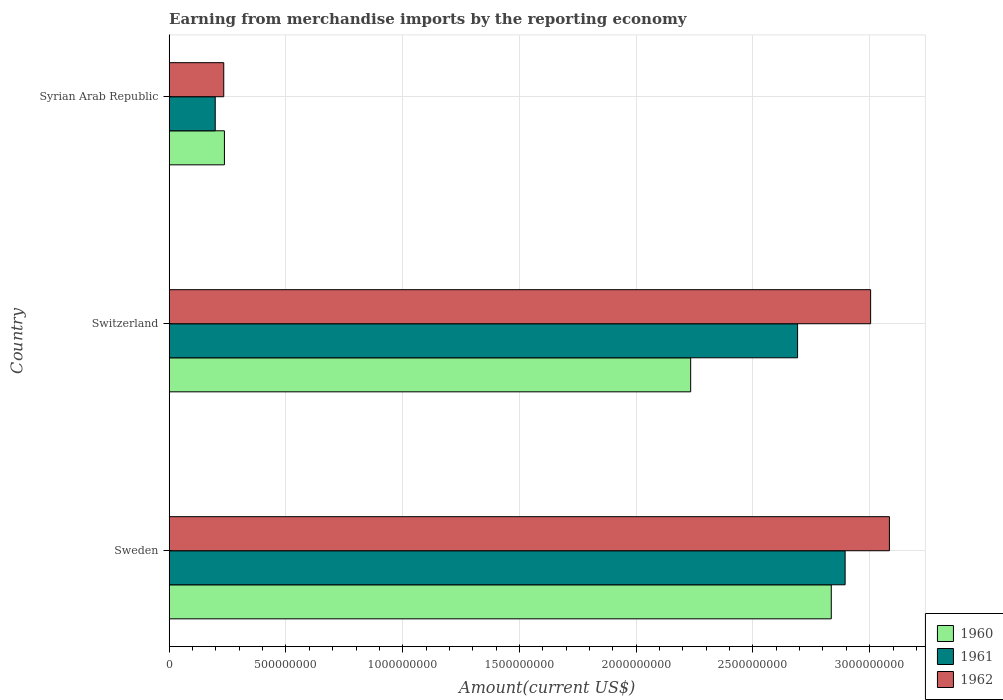How many groups of bars are there?
Keep it short and to the point. 3. Are the number of bars on each tick of the Y-axis equal?
Your response must be concise. Yes. How many bars are there on the 3rd tick from the bottom?
Offer a terse response. 3. What is the label of the 2nd group of bars from the top?
Make the answer very short. Switzerland. What is the amount earned from merchandise imports in 1960 in Switzerland?
Offer a terse response. 2.23e+09. Across all countries, what is the maximum amount earned from merchandise imports in 1960?
Your response must be concise. 2.84e+09. Across all countries, what is the minimum amount earned from merchandise imports in 1962?
Keep it short and to the point. 2.34e+08. In which country was the amount earned from merchandise imports in 1960 maximum?
Provide a succinct answer. Sweden. In which country was the amount earned from merchandise imports in 1962 minimum?
Offer a terse response. Syrian Arab Republic. What is the total amount earned from merchandise imports in 1962 in the graph?
Ensure brevity in your answer.  6.32e+09. What is the difference between the amount earned from merchandise imports in 1962 in Sweden and that in Syrian Arab Republic?
Your answer should be very brief. 2.85e+09. What is the difference between the amount earned from merchandise imports in 1960 in Syrian Arab Republic and the amount earned from merchandise imports in 1962 in Switzerland?
Your answer should be compact. -2.77e+09. What is the average amount earned from merchandise imports in 1962 per country?
Give a very brief answer. 2.11e+09. What is the difference between the amount earned from merchandise imports in 1961 and amount earned from merchandise imports in 1962 in Switzerland?
Give a very brief answer. -3.13e+08. In how many countries, is the amount earned from merchandise imports in 1960 greater than 1400000000 US$?
Your answer should be compact. 2. What is the ratio of the amount earned from merchandise imports in 1960 in Sweden to that in Syrian Arab Republic?
Provide a short and direct response. 11.99. Is the difference between the amount earned from merchandise imports in 1961 in Sweden and Switzerland greater than the difference between the amount earned from merchandise imports in 1962 in Sweden and Switzerland?
Offer a terse response. Yes. What is the difference between the highest and the second highest amount earned from merchandise imports in 1962?
Keep it short and to the point. 8.05e+07. What is the difference between the highest and the lowest amount earned from merchandise imports in 1960?
Ensure brevity in your answer.  2.60e+09. Is the sum of the amount earned from merchandise imports in 1961 in Switzerland and Syrian Arab Republic greater than the maximum amount earned from merchandise imports in 1960 across all countries?
Your response must be concise. Yes. What does the 3rd bar from the bottom in Sweden represents?
Provide a succinct answer. 1962. Is it the case that in every country, the sum of the amount earned from merchandise imports in 1961 and amount earned from merchandise imports in 1962 is greater than the amount earned from merchandise imports in 1960?
Keep it short and to the point. Yes. How many bars are there?
Your answer should be very brief. 9. Are all the bars in the graph horizontal?
Your answer should be compact. Yes. What is the difference between two consecutive major ticks on the X-axis?
Provide a short and direct response. 5.00e+08. Are the values on the major ticks of X-axis written in scientific E-notation?
Provide a succinct answer. No. How many legend labels are there?
Offer a terse response. 3. How are the legend labels stacked?
Ensure brevity in your answer.  Vertical. What is the title of the graph?
Keep it short and to the point. Earning from merchandise imports by the reporting economy. What is the label or title of the X-axis?
Offer a very short reply. Amount(current US$). What is the label or title of the Y-axis?
Provide a short and direct response. Country. What is the Amount(current US$) in 1960 in Sweden?
Your answer should be compact. 2.84e+09. What is the Amount(current US$) of 1961 in Sweden?
Ensure brevity in your answer.  2.89e+09. What is the Amount(current US$) in 1962 in Sweden?
Keep it short and to the point. 3.08e+09. What is the Amount(current US$) in 1960 in Switzerland?
Make the answer very short. 2.23e+09. What is the Amount(current US$) in 1961 in Switzerland?
Offer a very short reply. 2.69e+09. What is the Amount(current US$) in 1962 in Switzerland?
Offer a terse response. 3.00e+09. What is the Amount(current US$) in 1960 in Syrian Arab Republic?
Make the answer very short. 2.36e+08. What is the Amount(current US$) of 1961 in Syrian Arab Republic?
Offer a terse response. 1.97e+08. What is the Amount(current US$) in 1962 in Syrian Arab Republic?
Offer a very short reply. 2.34e+08. Across all countries, what is the maximum Amount(current US$) in 1960?
Offer a very short reply. 2.84e+09. Across all countries, what is the maximum Amount(current US$) of 1961?
Ensure brevity in your answer.  2.89e+09. Across all countries, what is the maximum Amount(current US$) of 1962?
Provide a short and direct response. 3.08e+09. Across all countries, what is the minimum Amount(current US$) in 1960?
Keep it short and to the point. 2.36e+08. Across all countries, what is the minimum Amount(current US$) in 1961?
Your response must be concise. 1.97e+08. Across all countries, what is the minimum Amount(current US$) of 1962?
Offer a terse response. 2.34e+08. What is the total Amount(current US$) in 1960 in the graph?
Provide a short and direct response. 5.31e+09. What is the total Amount(current US$) in 1961 in the graph?
Your response must be concise. 5.78e+09. What is the total Amount(current US$) of 1962 in the graph?
Make the answer very short. 6.32e+09. What is the difference between the Amount(current US$) of 1960 in Sweden and that in Switzerland?
Your answer should be very brief. 6.02e+08. What is the difference between the Amount(current US$) of 1961 in Sweden and that in Switzerland?
Offer a very short reply. 2.04e+08. What is the difference between the Amount(current US$) in 1962 in Sweden and that in Switzerland?
Offer a very short reply. 8.05e+07. What is the difference between the Amount(current US$) of 1960 in Sweden and that in Syrian Arab Republic?
Keep it short and to the point. 2.60e+09. What is the difference between the Amount(current US$) of 1961 in Sweden and that in Syrian Arab Republic?
Make the answer very short. 2.70e+09. What is the difference between the Amount(current US$) in 1962 in Sweden and that in Syrian Arab Republic?
Offer a terse response. 2.85e+09. What is the difference between the Amount(current US$) in 1960 in Switzerland and that in Syrian Arab Republic?
Your answer should be compact. 2.00e+09. What is the difference between the Amount(current US$) in 1961 in Switzerland and that in Syrian Arab Republic?
Offer a terse response. 2.49e+09. What is the difference between the Amount(current US$) in 1962 in Switzerland and that in Syrian Arab Republic?
Offer a terse response. 2.77e+09. What is the difference between the Amount(current US$) of 1960 in Sweden and the Amount(current US$) of 1961 in Switzerland?
Your answer should be compact. 1.44e+08. What is the difference between the Amount(current US$) in 1960 in Sweden and the Amount(current US$) in 1962 in Switzerland?
Your answer should be compact. -1.68e+08. What is the difference between the Amount(current US$) in 1961 in Sweden and the Amount(current US$) in 1962 in Switzerland?
Ensure brevity in your answer.  -1.09e+08. What is the difference between the Amount(current US$) in 1960 in Sweden and the Amount(current US$) in 1961 in Syrian Arab Republic?
Provide a succinct answer. 2.64e+09. What is the difference between the Amount(current US$) in 1960 in Sweden and the Amount(current US$) in 1962 in Syrian Arab Republic?
Keep it short and to the point. 2.60e+09. What is the difference between the Amount(current US$) of 1961 in Sweden and the Amount(current US$) of 1962 in Syrian Arab Republic?
Offer a very short reply. 2.66e+09. What is the difference between the Amount(current US$) in 1960 in Switzerland and the Amount(current US$) in 1961 in Syrian Arab Republic?
Your answer should be compact. 2.04e+09. What is the difference between the Amount(current US$) of 1960 in Switzerland and the Amount(current US$) of 1962 in Syrian Arab Republic?
Offer a very short reply. 2.00e+09. What is the difference between the Amount(current US$) in 1961 in Switzerland and the Amount(current US$) in 1962 in Syrian Arab Republic?
Your answer should be compact. 2.46e+09. What is the average Amount(current US$) in 1960 per country?
Your response must be concise. 1.77e+09. What is the average Amount(current US$) in 1961 per country?
Offer a very short reply. 1.93e+09. What is the average Amount(current US$) in 1962 per country?
Ensure brevity in your answer.  2.11e+09. What is the difference between the Amount(current US$) of 1960 and Amount(current US$) of 1961 in Sweden?
Give a very brief answer. -5.93e+07. What is the difference between the Amount(current US$) of 1960 and Amount(current US$) of 1962 in Sweden?
Your answer should be very brief. -2.49e+08. What is the difference between the Amount(current US$) of 1961 and Amount(current US$) of 1962 in Sweden?
Offer a terse response. -1.90e+08. What is the difference between the Amount(current US$) in 1960 and Amount(current US$) in 1961 in Switzerland?
Provide a succinct answer. -4.58e+08. What is the difference between the Amount(current US$) of 1960 and Amount(current US$) of 1962 in Switzerland?
Provide a succinct answer. -7.71e+08. What is the difference between the Amount(current US$) in 1961 and Amount(current US$) in 1962 in Switzerland?
Provide a short and direct response. -3.13e+08. What is the difference between the Amount(current US$) of 1960 and Amount(current US$) of 1961 in Syrian Arab Republic?
Your answer should be very brief. 3.94e+07. What is the difference between the Amount(current US$) in 1960 and Amount(current US$) in 1962 in Syrian Arab Republic?
Provide a succinct answer. 2.90e+06. What is the difference between the Amount(current US$) of 1961 and Amount(current US$) of 1962 in Syrian Arab Republic?
Ensure brevity in your answer.  -3.65e+07. What is the ratio of the Amount(current US$) of 1960 in Sweden to that in Switzerland?
Make the answer very short. 1.27. What is the ratio of the Amount(current US$) of 1961 in Sweden to that in Switzerland?
Provide a succinct answer. 1.08. What is the ratio of the Amount(current US$) of 1962 in Sweden to that in Switzerland?
Provide a succinct answer. 1.03. What is the ratio of the Amount(current US$) of 1960 in Sweden to that in Syrian Arab Republic?
Offer a very short reply. 11.99. What is the ratio of the Amount(current US$) of 1961 in Sweden to that in Syrian Arab Republic?
Provide a short and direct response. 14.69. What is the ratio of the Amount(current US$) of 1962 in Sweden to that in Syrian Arab Republic?
Provide a short and direct response. 13.2. What is the ratio of the Amount(current US$) of 1960 in Switzerland to that in Syrian Arab Republic?
Give a very brief answer. 9.44. What is the ratio of the Amount(current US$) in 1961 in Switzerland to that in Syrian Arab Republic?
Provide a short and direct response. 13.65. What is the ratio of the Amount(current US$) of 1962 in Switzerland to that in Syrian Arab Republic?
Your response must be concise. 12.86. What is the difference between the highest and the second highest Amount(current US$) of 1960?
Offer a very short reply. 6.02e+08. What is the difference between the highest and the second highest Amount(current US$) in 1961?
Your response must be concise. 2.04e+08. What is the difference between the highest and the second highest Amount(current US$) of 1962?
Keep it short and to the point. 8.05e+07. What is the difference between the highest and the lowest Amount(current US$) in 1960?
Ensure brevity in your answer.  2.60e+09. What is the difference between the highest and the lowest Amount(current US$) in 1961?
Ensure brevity in your answer.  2.70e+09. What is the difference between the highest and the lowest Amount(current US$) in 1962?
Your response must be concise. 2.85e+09. 